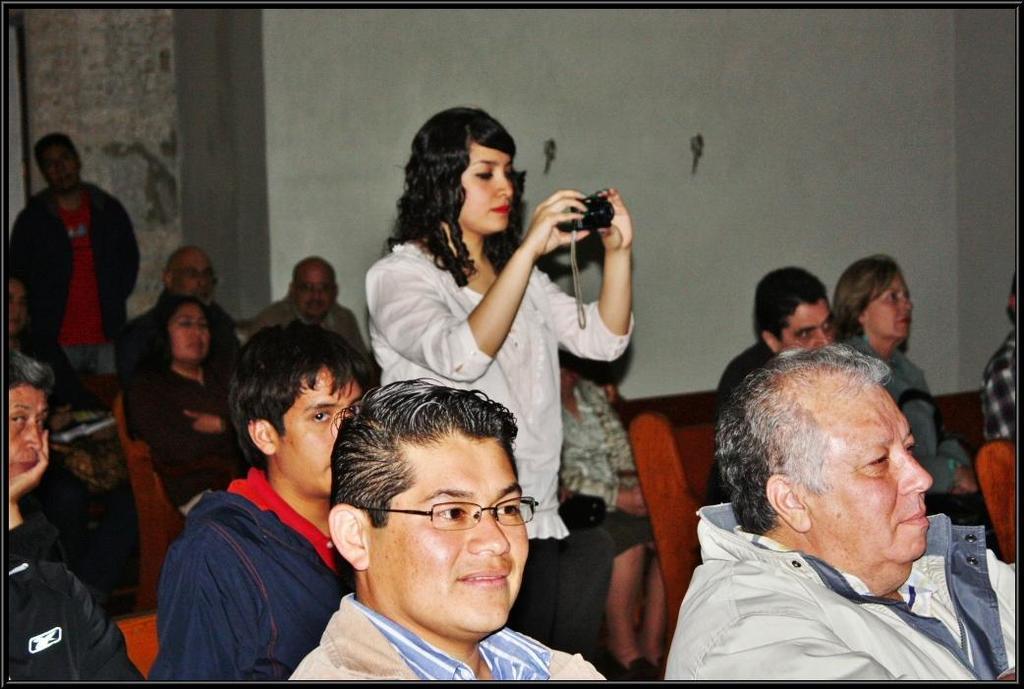How would you summarize this image in a sentence or two? In this image, we can see people wearing clothes. There is a person in the middle of the image holding a camera with her hands. In the background, we can see a wall. 